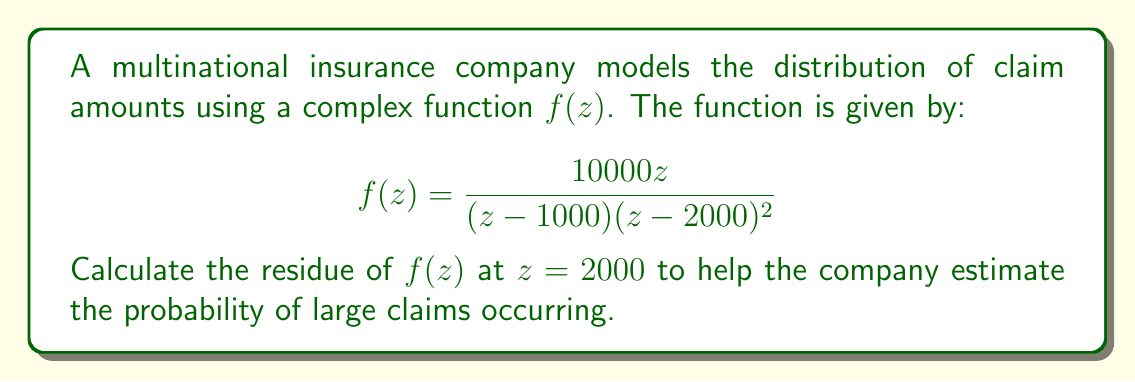Give your solution to this math problem. To evaluate the residue of $f(z)$ at $z = 2000$, we need to determine the order of the pole at this point and use the appropriate method.

1) First, we observe that $z = 2000$ is a pole of order 2 for $f(z)$, as $(z-2000)^2$ appears in the denominator.

2) For a pole of order 2, we can use the formula:

   $$\text{Res}(f,2000) = \lim_{z \to 2000} \frac{d}{dz}[(z-2000)^2f(z)]$$

3) Let's simplify $(z-2000)^2f(z)$:

   $$(z-2000)^2f(z) = \frac{10000z}{(z-1000)}$$

4) Now we need to differentiate this with respect to $z$:

   $$\frac{d}{dz}\left[\frac{10000z}{(z-1000)}\right] = \frac{10000(z-1000) - 10000z}{(z-1000)^2} = \frac{-10000000}{(z-1000)^2}$$

5) Finally, we take the limit as $z$ approaches 2000:

   $$\lim_{z \to 2000} \frac{-10000000}{(z-1000)^2} = \frac{-10000000}{1000^2} = -10$$

Therefore, the residue of $f(z)$ at $z = 2000$ is $-10$.

This residue can be used in contour integration to calculate probabilities related to large claims, helping the insurance company estimate potential financial losses and adjust their risk management strategies accordingly.
Answer: $-10$ 